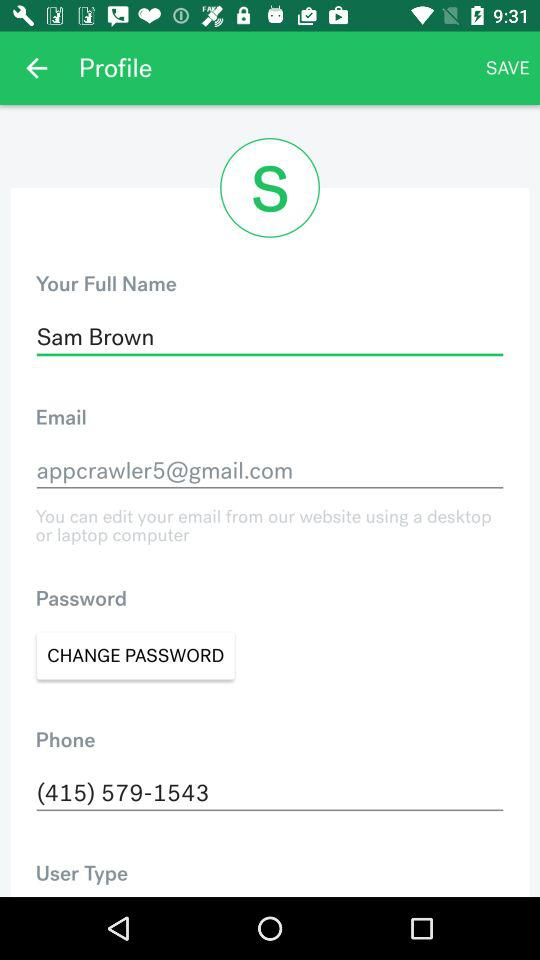What's the phone number? The phone number is 415-579-1543. 